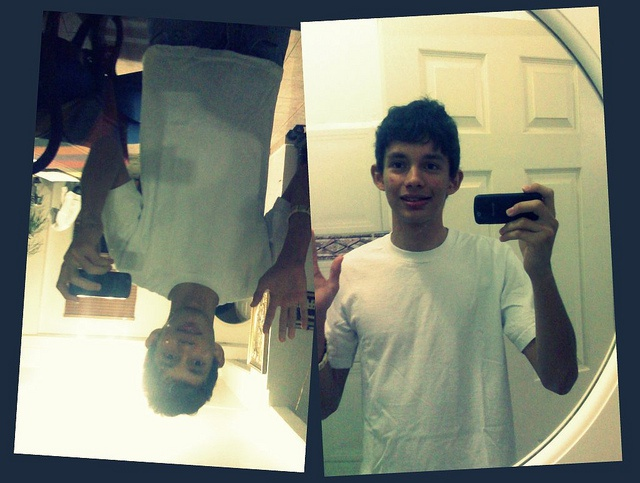Describe the objects in this image and their specific colors. I can see people in black, darkgray, and gray tones, people in black and gray tones, cell phone in black, navy, and gray tones, and cell phone in black, blue, teal, darkblue, and beige tones in this image. 